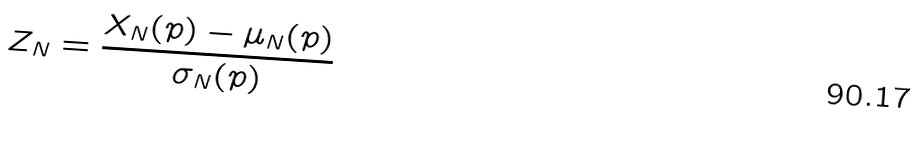<formula> <loc_0><loc_0><loc_500><loc_500>Z _ { N } = \frac { X _ { N } ( p ) - \mu _ { N } ( p ) } { \sigma _ { N } ( p ) }</formula> 